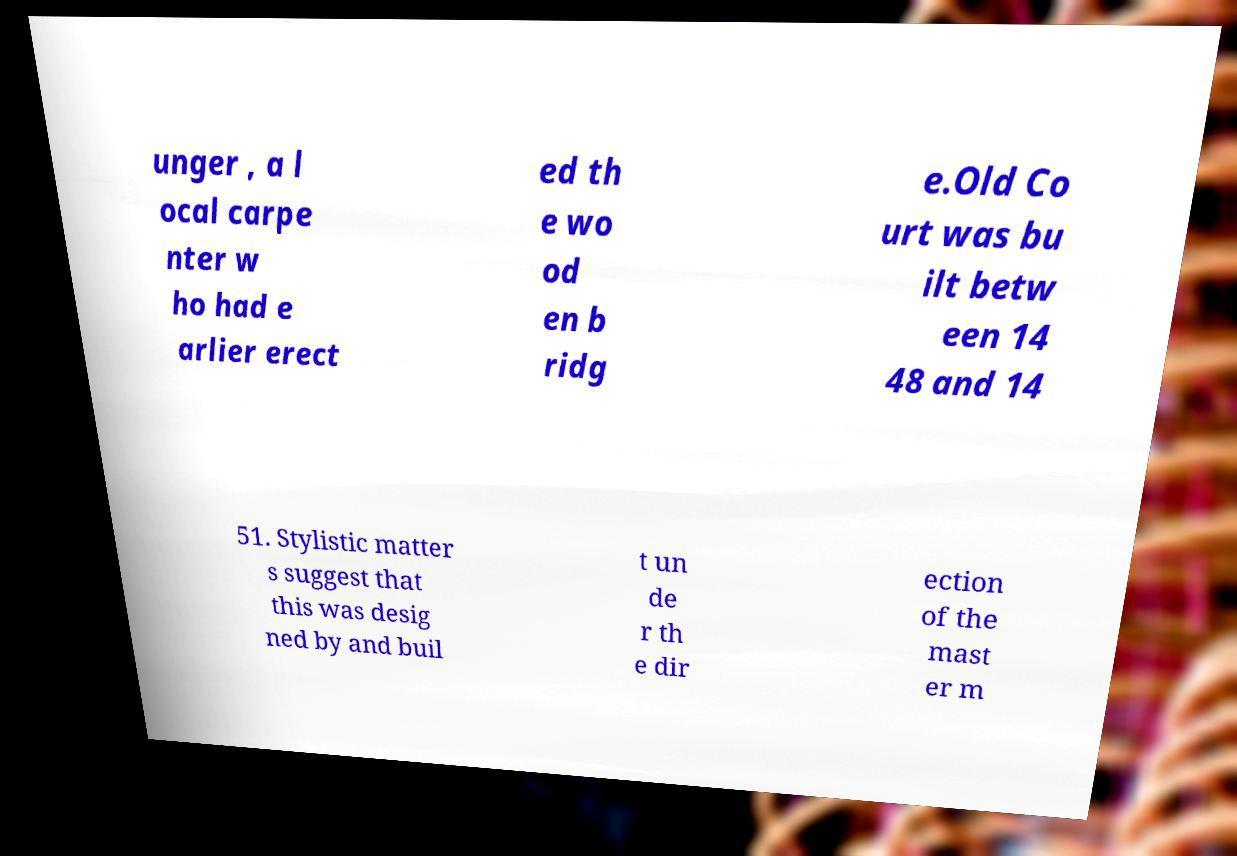Could you extract and type out the text from this image? unger , a l ocal carpe nter w ho had e arlier erect ed th e wo od en b ridg e.Old Co urt was bu ilt betw een 14 48 and 14 51. Stylistic matter s suggest that this was desig ned by and buil t un de r th e dir ection of the mast er m 